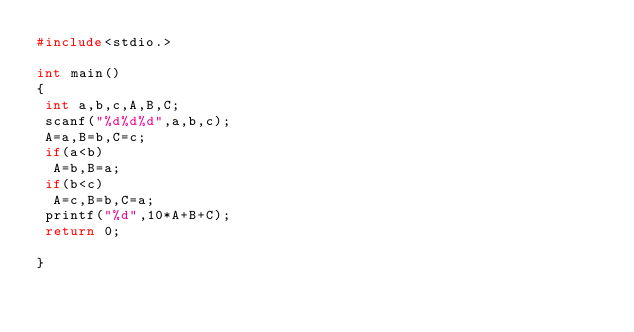Convert code to text. <code><loc_0><loc_0><loc_500><loc_500><_C_>#include<stdio.>

int main()
{
 int a,b,c,A,B,C;
 scanf("%d%d%d",a,b,c);
 A=a,B=b,C=c;
 if(a<b)
  A=b,B=a;
 if(b<c)
  A=c,B=b,C=a;
 printf("%d",10*A+B+C);
 return 0;
 
}</code> 